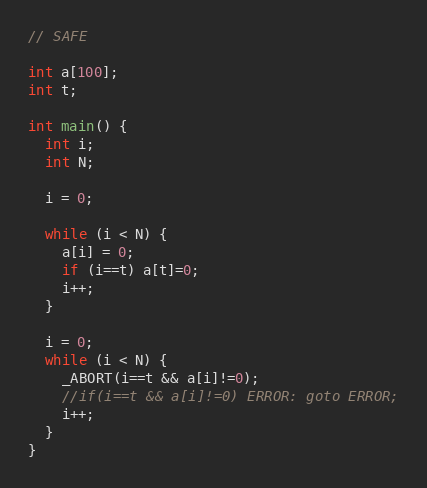Convert code to text. <code><loc_0><loc_0><loc_500><loc_500><_C_>// SAFE

int a[100];
int t;

int main() {
  int i;
  int N;
  
  i = 0;

  while (i < N) {
    a[i] = 0;
    if (i==t) a[t]=0;
    i++;
  }
  
  i = 0;
  while (i < N) {
    _ABORT(i==t && a[i]!=0); 	  
    //if(i==t && a[i]!=0) ERROR: goto ERROR;
    i++;
  }
}
</code> 